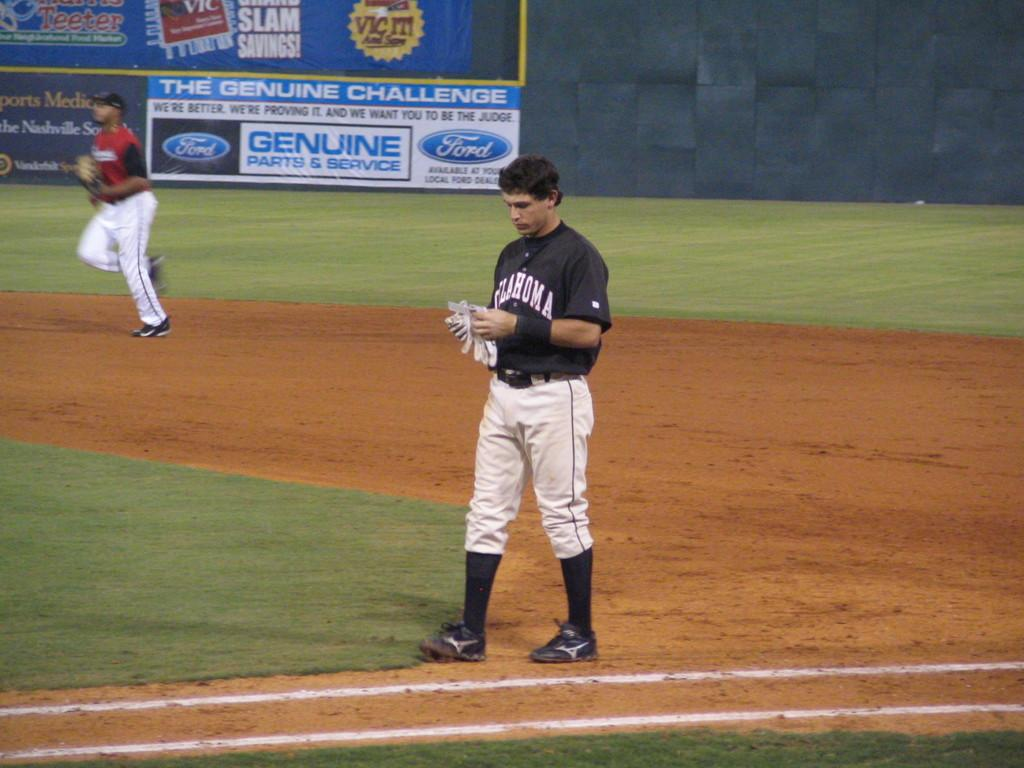<image>
Summarize the visual content of the image. a baseball player and a sign that says Genuine Challenge 